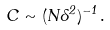Convert formula to latex. <formula><loc_0><loc_0><loc_500><loc_500>C \sim ( N \Lambda ^ { 2 } ) ^ { - 1 } \, .</formula> 